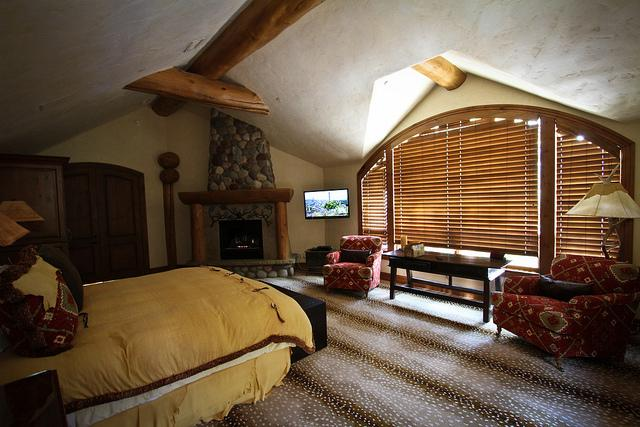What is the rectangular image in the corner of the room? television 